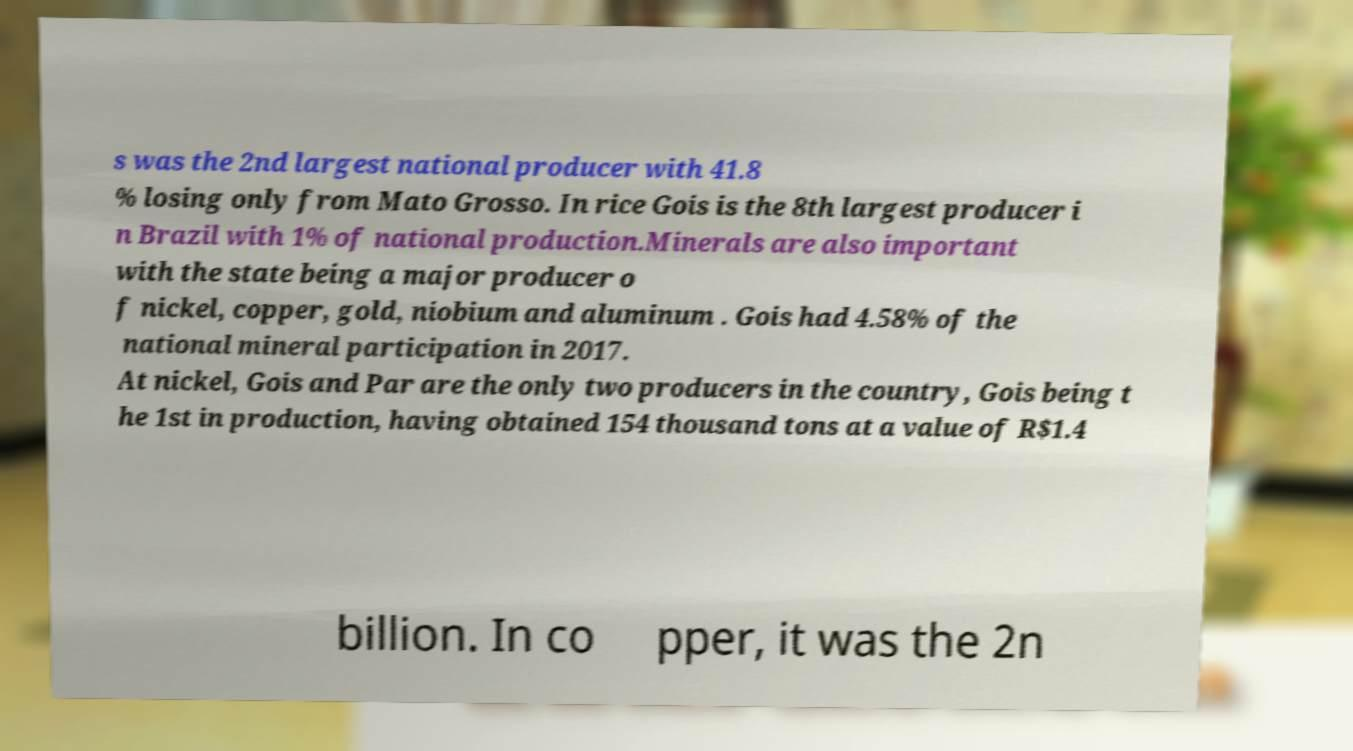Could you extract and type out the text from this image? s was the 2nd largest national producer with 41.8 % losing only from Mato Grosso. In rice Gois is the 8th largest producer i n Brazil with 1% of national production.Minerals are also important with the state being a major producer o f nickel, copper, gold, niobium and aluminum . Gois had 4.58% of the national mineral participation in 2017. At nickel, Gois and Par are the only two producers in the country, Gois being t he 1st in production, having obtained 154 thousand tons at a value of R$1.4 billion. In co pper, it was the 2n 